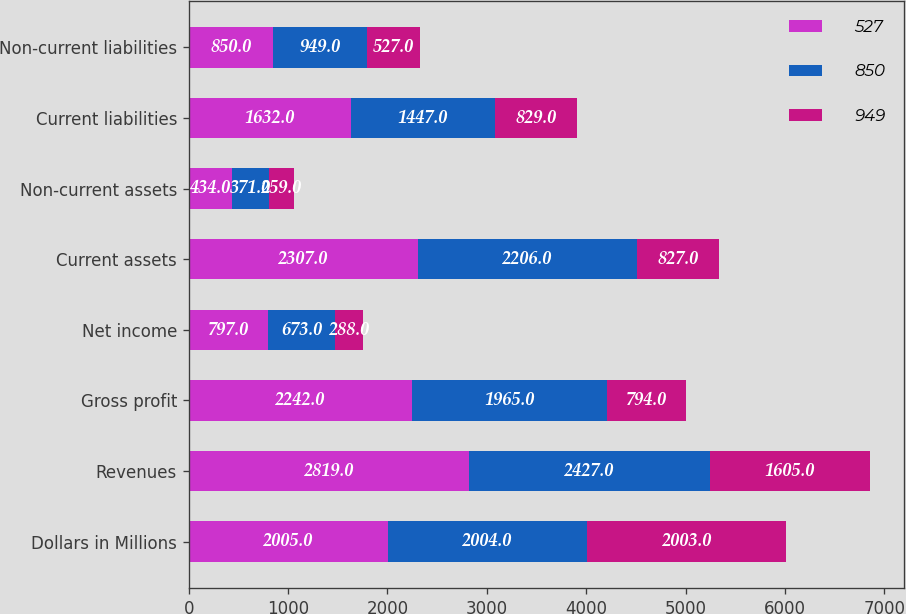<chart> <loc_0><loc_0><loc_500><loc_500><stacked_bar_chart><ecel><fcel>Dollars in Millions<fcel>Revenues<fcel>Gross profit<fcel>Net income<fcel>Current assets<fcel>Non-current assets<fcel>Current liabilities<fcel>Non-current liabilities<nl><fcel>527<fcel>2005<fcel>2819<fcel>2242<fcel>797<fcel>2307<fcel>434<fcel>1632<fcel>850<nl><fcel>850<fcel>2004<fcel>2427<fcel>1965<fcel>673<fcel>2206<fcel>371<fcel>1447<fcel>949<nl><fcel>949<fcel>2003<fcel>1605<fcel>794<fcel>288<fcel>827<fcel>259<fcel>829<fcel>527<nl></chart> 